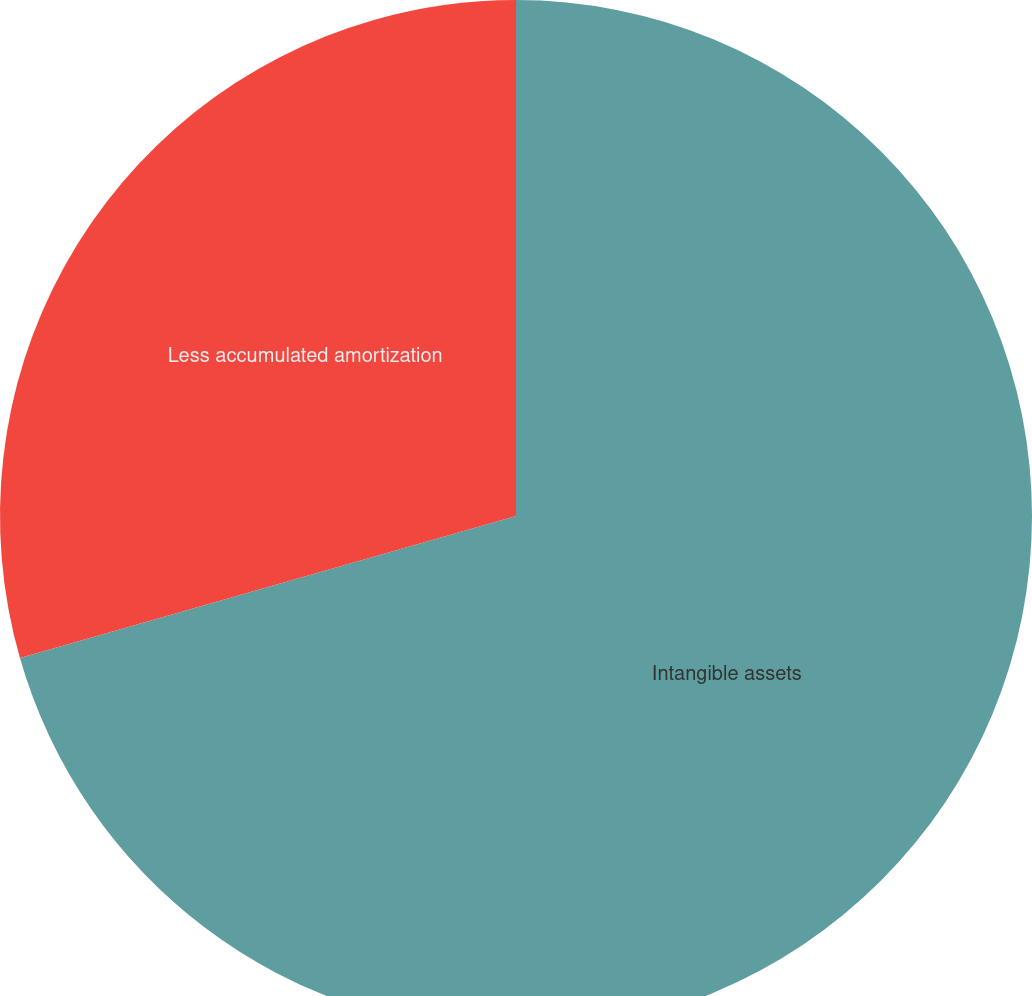Convert chart to OTSL. <chart><loc_0><loc_0><loc_500><loc_500><pie_chart><fcel>Intangible assets<fcel>Less accumulated amortization<nl><fcel>70.56%<fcel>29.44%<nl></chart> 